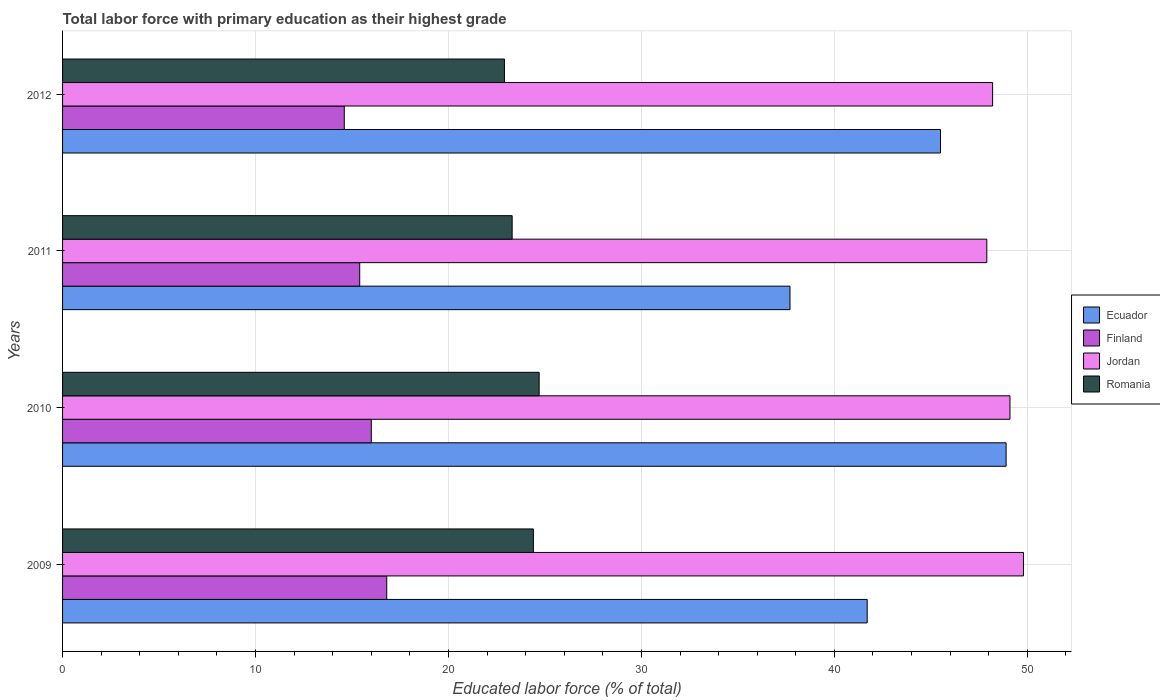Are the number of bars per tick equal to the number of legend labels?
Keep it short and to the point. Yes. How many bars are there on the 4th tick from the top?
Offer a terse response. 4. In how many cases, is the number of bars for a given year not equal to the number of legend labels?
Give a very brief answer. 0. What is the percentage of total labor force with primary education in Finland in 2010?
Your answer should be compact. 16. Across all years, what is the maximum percentage of total labor force with primary education in Finland?
Keep it short and to the point. 16.8. Across all years, what is the minimum percentage of total labor force with primary education in Ecuador?
Make the answer very short. 37.7. In which year was the percentage of total labor force with primary education in Ecuador maximum?
Offer a very short reply. 2010. In which year was the percentage of total labor force with primary education in Jordan minimum?
Offer a terse response. 2011. What is the total percentage of total labor force with primary education in Jordan in the graph?
Your answer should be very brief. 195. What is the difference between the percentage of total labor force with primary education in Finland in 2009 and that in 2011?
Ensure brevity in your answer.  1.4. What is the difference between the percentage of total labor force with primary education in Ecuador in 2011 and the percentage of total labor force with primary education in Romania in 2012?
Give a very brief answer. 14.8. What is the average percentage of total labor force with primary education in Jordan per year?
Make the answer very short. 48.75. In the year 2009, what is the difference between the percentage of total labor force with primary education in Jordan and percentage of total labor force with primary education in Ecuador?
Your answer should be very brief. 8.1. What is the ratio of the percentage of total labor force with primary education in Jordan in 2011 to that in 2012?
Make the answer very short. 0.99. What is the difference between the highest and the second highest percentage of total labor force with primary education in Ecuador?
Offer a terse response. 3.4. What is the difference between the highest and the lowest percentage of total labor force with primary education in Jordan?
Keep it short and to the point. 1.9. In how many years, is the percentage of total labor force with primary education in Finland greater than the average percentage of total labor force with primary education in Finland taken over all years?
Your answer should be compact. 2. What does the 3rd bar from the top in 2010 represents?
Make the answer very short. Finland. What does the 1st bar from the bottom in 2009 represents?
Make the answer very short. Ecuador. How many bars are there?
Keep it short and to the point. 16. Are all the bars in the graph horizontal?
Give a very brief answer. Yes. What is the difference between two consecutive major ticks on the X-axis?
Your response must be concise. 10. Are the values on the major ticks of X-axis written in scientific E-notation?
Your response must be concise. No. Does the graph contain any zero values?
Offer a very short reply. No. Where does the legend appear in the graph?
Ensure brevity in your answer.  Center right. What is the title of the graph?
Your answer should be very brief. Total labor force with primary education as their highest grade. What is the label or title of the X-axis?
Offer a very short reply. Educated labor force (% of total). What is the label or title of the Y-axis?
Your answer should be very brief. Years. What is the Educated labor force (% of total) in Ecuador in 2009?
Offer a terse response. 41.7. What is the Educated labor force (% of total) in Finland in 2009?
Give a very brief answer. 16.8. What is the Educated labor force (% of total) of Jordan in 2009?
Give a very brief answer. 49.8. What is the Educated labor force (% of total) of Romania in 2009?
Your response must be concise. 24.4. What is the Educated labor force (% of total) in Ecuador in 2010?
Ensure brevity in your answer.  48.9. What is the Educated labor force (% of total) of Finland in 2010?
Provide a short and direct response. 16. What is the Educated labor force (% of total) of Jordan in 2010?
Ensure brevity in your answer.  49.1. What is the Educated labor force (% of total) of Romania in 2010?
Your response must be concise. 24.7. What is the Educated labor force (% of total) of Ecuador in 2011?
Your response must be concise. 37.7. What is the Educated labor force (% of total) of Finland in 2011?
Offer a very short reply. 15.4. What is the Educated labor force (% of total) of Jordan in 2011?
Your answer should be very brief. 47.9. What is the Educated labor force (% of total) in Romania in 2011?
Keep it short and to the point. 23.3. What is the Educated labor force (% of total) of Ecuador in 2012?
Your answer should be compact. 45.5. What is the Educated labor force (% of total) in Finland in 2012?
Offer a terse response. 14.6. What is the Educated labor force (% of total) of Jordan in 2012?
Give a very brief answer. 48.2. What is the Educated labor force (% of total) of Romania in 2012?
Provide a short and direct response. 22.9. Across all years, what is the maximum Educated labor force (% of total) in Ecuador?
Provide a succinct answer. 48.9. Across all years, what is the maximum Educated labor force (% of total) of Finland?
Your answer should be compact. 16.8. Across all years, what is the maximum Educated labor force (% of total) of Jordan?
Make the answer very short. 49.8. Across all years, what is the maximum Educated labor force (% of total) of Romania?
Your response must be concise. 24.7. Across all years, what is the minimum Educated labor force (% of total) in Ecuador?
Your answer should be very brief. 37.7. Across all years, what is the minimum Educated labor force (% of total) of Finland?
Your answer should be very brief. 14.6. Across all years, what is the minimum Educated labor force (% of total) in Jordan?
Give a very brief answer. 47.9. Across all years, what is the minimum Educated labor force (% of total) of Romania?
Offer a very short reply. 22.9. What is the total Educated labor force (% of total) of Ecuador in the graph?
Offer a very short reply. 173.8. What is the total Educated labor force (% of total) in Finland in the graph?
Give a very brief answer. 62.8. What is the total Educated labor force (% of total) in Jordan in the graph?
Your response must be concise. 195. What is the total Educated labor force (% of total) in Romania in the graph?
Provide a succinct answer. 95.3. What is the difference between the Educated labor force (% of total) in Jordan in 2009 and that in 2010?
Give a very brief answer. 0.7. What is the difference between the Educated labor force (% of total) of Ecuador in 2009 and that in 2011?
Ensure brevity in your answer.  4. What is the difference between the Educated labor force (% of total) of Jordan in 2009 and that in 2012?
Keep it short and to the point. 1.6. What is the difference between the Educated labor force (% of total) in Jordan in 2010 and that in 2011?
Make the answer very short. 1.2. What is the difference between the Educated labor force (% of total) in Romania in 2010 and that in 2011?
Your answer should be compact. 1.4. What is the difference between the Educated labor force (% of total) of Finland in 2010 and that in 2012?
Provide a succinct answer. 1.4. What is the difference between the Educated labor force (% of total) in Romania in 2010 and that in 2012?
Ensure brevity in your answer.  1.8. What is the difference between the Educated labor force (% of total) of Ecuador in 2011 and that in 2012?
Offer a very short reply. -7.8. What is the difference between the Educated labor force (% of total) in Finland in 2011 and that in 2012?
Offer a terse response. 0.8. What is the difference between the Educated labor force (% of total) of Ecuador in 2009 and the Educated labor force (% of total) of Finland in 2010?
Your answer should be compact. 25.7. What is the difference between the Educated labor force (% of total) in Ecuador in 2009 and the Educated labor force (% of total) in Romania in 2010?
Provide a short and direct response. 17. What is the difference between the Educated labor force (% of total) in Finland in 2009 and the Educated labor force (% of total) in Jordan in 2010?
Provide a succinct answer. -32.3. What is the difference between the Educated labor force (% of total) in Finland in 2009 and the Educated labor force (% of total) in Romania in 2010?
Your answer should be very brief. -7.9. What is the difference between the Educated labor force (% of total) of Jordan in 2009 and the Educated labor force (% of total) of Romania in 2010?
Provide a short and direct response. 25.1. What is the difference between the Educated labor force (% of total) of Ecuador in 2009 and the Educated labor force (% of total) of Finland in 2011?
Provide a succinct answer. 26.3. What is the difference between the Educated labor force (% of total) in Ecuador in 2009 and the Educated labor force (% of total) in Romania in 2011?
Ensure brevity in your answer.  18.4. What is the difference between the Educated labor force (% of total) in Finland in 2009 and the Educated labor force (% of total) in Jordan in 2011?
Offer a very short reply. -31.1. What is the difference between the Educated labor force (% of total) in Finland in 2009 and the Educated labor force (% of total) in Romania in 2011?
Provide a short and direct response. -6.5. What is the difference between the Educated labor force (% of total) of Jordan in 2009 and the Educated labor force (% of total) of Romania in 2011?
Offer a very short reply. 26.5. What is the difference between the Educated labor force (% of total) of Ecuador in 2009 and the Educated labor force (% of total) of Finland in 2012?
Your answer should be compact. 27.1. What is the difference between the Educated labor force (% of total) in Finland in 2009 and the Educated labor force (% of total) in Jordan in 2012?
Offer a terse response. -31.4. What is the difference between the Educated labor force (% of total) of Jordan in 2009 and the Educated labor force (% of total) of Romania in 2012?
Give a very brief answer. 26.9. What is the difference between the Educated labor force (% of total) in Ecuador in 2010 and the Educated labor force (% of total) in Finland in 2011?
Keep it short and to the point. 33.5. What is the difference between the Educated labor force (% of total) in Ecuador in 2010 and the Educated labor force (% of total) in Romania in 2011?
Give a very brief answer. 25.6. What is the difference between the Educated labor force (% of total) in Finland in 2010 and the Educated labor force (% of total) in Jordan in 2011?
Ensure brevity in your answer.  -31.9. What is the difference between the Educated labor force (% of total) in Jordan in 2010 and the Educated labor force (% of total) in Romania in 2011?
Offer a very short reply. 25.8. What is the difference between the Educated labor force (% of total) of Ecuador in 2010 and the Educated labor force (% of total) of Finland in 2012?
Your answer should be compact. 34.3. What is the difference between the Educated labor force (% of total) of Finland in 2010 and the Educated labor force (% of total) of Jordan in 2012?
Provide a short and direct response. -32.2. What is the difference between the Educated labor force (% of total) in Finland in 2010 and the Educated labor force (% of total) in Romania in 2012?
Keep it short and to the point. -6.9. What is the difference between the Educated labor force (% of total) of Jordan in 2010 and the Educated labor force (% of total) of Romania in 2012?
Offer a terse response. 26.2. What is the difference between the Educated labor force (% of total) of Ecuador in 2011 and the Educated labor force (% of total) of Finland in 2012?
Ensure brevity in your answer.  23.1. What is the difference between the Educated labor force (% of total) of Ecuador in 2011 and the Educated labor force (% of total) of Jordan in 2012?
Provide a short and direct response. -10.5. What is the difference between the Educated labor force (% of total) in Ecuador in 2011 and the Educated labor force (% of total) in Romania in 2012?
Give a very brief answer. 14.8. What is the difference between the Educated labor force (% of total) of Finland in 2011 and the Educated labor force (% of total) of Jordan in 2012?
Offer a terse response. -32.8. What is the difference between the Educated labor force (% of total) of Finland in 2011 and the Educated labor force (% of total) of Romania in 2012?
Offer a terse response. -7.5. What is the average Educated labor force (% of total) of Ecuador per year?
Provide a short and direct response. 43.45. What is the average Educated labor force (% of total) of Finland per year?
Your answer should be very brief. 15.7. What is the average Educated labor force (% of total) in Jordan per year?
Give a very brief answer. 48.75. What is the average Educated labor force (% of total) in Romania per year?
Offer a very short reply. 23.82. In the year 2009, what is the difference between the Educated labor force (% of total) of Ecuador and Educated labor force (% of total) of Finland?
Ensure brevity in your answer.  24.9. In the year 2009, what is the difference between the Educated labor force (% of total) of Ecuador and Educated labor force (% of total) of Jordan?
Your response must be concise. -8.1. In the year 2009, what is the difference between the Educated labor force (% of total) in Ecuador and Educated labor force (% of total) in Romania?
Your answer should be compact. 17.3. In the year 2009, what is the difference between the Educated labor force (% of total) of Finland and Educated labor force (% of total) of Jordan?
Your answer should be very brief. -33. In the year 2009, what is the difference between the Educated labor force (% of total) of Finland and Educated labor force (% of total) of Romania?
Your answer should be very brief. -7.6. In the year 2009, what is the difference between the Educated labor force (% of total) in Jordan and Educated labor force (% of total) in Romania?
Your response must be concise. 25.4. In the year 2010, what is the difference between the Educated labor force (% of total) in Ecuador and Educated labor force (% of total) in Finland?
Keep it short and to the point. 32.9. In the year 2010, what is the difference between the Educated labor force (% of total) in Ecuador and Educated labor force (% of total) in Jordan?
Keep it short and to the point. -0.2. In the year 2010, what is the difference between the Educated labor force (% of total) of Ecuador and Educated labor force (% of total) of Romania?
Offer a very short reply. 24.2. In the year 2010, what is the difference between the Educated labor force (% of total) in Finland and Educated labor force (% of total) in Jordan?
Ensure brevity in your answer.  -33.1. In the year 2010, what is the difference between the Educated labor force (% of total) in Jordan and Educated labor force (% of total) in Romania?
Your response must be concise. 24.4. In the year 2011, what is the difference between the Educated labor force (% of total) in Ecuador and Educated labor force (% of total) in Finland?
Your response must be concise. 22.3. In the year 2011, what is the difference between the Educated labor force (% of total) of Ecuador and Educated labor force (% of total) of Jordan?
Provide a succinct answer. -10.2. In the year 2011, what is the difference between the Educated labor force (% of total) in Finland and Educated labor force (% of total) in Jordan?
Provide a succinct answer. -32.5. In the year 2011, what is the difference between the Educated labor force (% of total) of Finland and Educated labor force (% of total) of Romania?
Give a very brief answer. -7.9. In the year 2011, what is the difference between the Educated labor force (% of total) in Jordan and Educated labor force (% of total) in Romania?
Make the answer very short. 24.6. In the year 2012, what is the difference between the Educated labor force (% of total) in Ecuador and Educated labor force (% of total) in Finland?
Ensure brevity in your answer.  30.9. In the year 2012, what is the difference between the Educated labor force (% of total) of Ecuador and Educated labor force (% of total) of Jordan?
Your response must be concise. -2.7. In the year 2012, what is the difference between the Educated labor force (% of total) of Ecuador and Educated labor force (% of total) of Romania?
Ensure brevity in your answer.  22.6. In the year 2012, what is the difference between the Educated labor force (% of total) in Finland and Educated labor force (% of total) in Jordan?
Offer a terse response. -33.6. In the year 2012, what is the difference between the Educated labor force (% of total) of Finland and Educated labor force (% of total) of Romania?
Give a very brief answer. -8.3. In the year 2012, what is the difference between the Educated labor force (% of total) of Jordan and Educated labor force (% of total) of Romania?
Make the answer very short. 25.3. What is the ratio of the Educated labor force (% of total) in Ecuador in 2009 to that in 2010?
Provide a succinct answer. 0.85. What is the ratio of the Educated labor force (% of total) of Finland in 2009 to that in 2010?
Provide a succinct answer. 1.05. What is the ratio of the Educated labor force (% of total) in Jordan in 2009 to that in 2010?
Give a very brief answer. 1.01. What is the ratio of the Educated labor force (% of total) of Romania in 2009 to that in 2010?
Your answer should be very brief. 0.99. What is the ratio of the Educated labor force (% of total) in Ecuador in 2009 to that in 2011?
Your response must be concise. 1.11. What is the ratio of the Educated labor force (% of total) in Finland in 2009 to that in 2011?
Your response must be concise. 1.09. What is the ratio of the Educated labor force (% of total) in Jordan in 2009 to that in 2011?
Offer a terse response. 1.04. What is the ratio of the Educated labor force (% of total) in Romania in 2009 to that in 2011?
Your answer should be compact. 1.05. What is the ratio of the Educated labor force (% of total) of Ecuador in 2009 to that in 2012?
Make the answer very short. 0.92. What is the ratio of the Educated labor force (% of total) in Finland in 2009 to that in 2012?
Make the answer very short. 1.15. What is the ratio of the Educated labor force (% of total) of Jordan in 2009 to that in 2012?
Ensure brevity in your answer.  1.03. What is the ratio of the Educated labor force (% of total) in Romania in 2009 to that in 2012?
Provide a succinct answer. 1.07. What is the ratio of the Educated labor force (% of total) in Ecuador in 2010 to that in 2011?
Give a very brief answer. 1.3. What is the ratio of the Educated labor force (% of total) in Finland in 2010 to that in 2011?
Ensure brevity in your answer.  1.04. What is the ratio of the Educated labor force (% of total) of Jordan in 2010 to that in 2011?
Give a very brief answer. 1.03. What is the ratio of the Educated labor force (% of total) in Romania in 2010 to that in 2011?
Provide a short and direct response. 1.06. What is the ratio of the Educated labor force (% of total) of Ecuador in 2010 to that in 2012?
Keep it short and to the point. 1.07. What is the ratio of the Educated labor force (% of total) in Finland in 2010 to that in 2012?
Your response must be concise. 1.1. What is the ratio of the Educated labor force (% of total) in Jordan in 2010 to that in 2012?
Give a very brief answer. 1.02. What is the ratio of the Educated labor force (% of total) in Romania in 2010 to that in 2012?
Your response must be concise. 1.08. What is the ratio of the Educated labor force (% of total) in Ecuador in 2011 to that in 2012?
Offer a very short reply. 0.83. What is the ratio of the Educated labor force (% of total) of Finland in 2011 to that in 2012?
Keep it short and to the point. 1.05. What is the ratio of the Educated labor force (% of total) in Romania in 2011 to that in 2012?
Offer a terse response. 1.02. What is the difference between the highest and the second highest Educated labor force (% of total) in Ecuador?
Give a very brief answer. 3.4. What is the difference between the highest and the lowest Educated labor force (% of total) of Finland?
Keep it short and to the point. 2.2. What is the difference between the highest and the lowest Educated labor force (% of total) in Romania?
Offer a terse response. 1.8. 